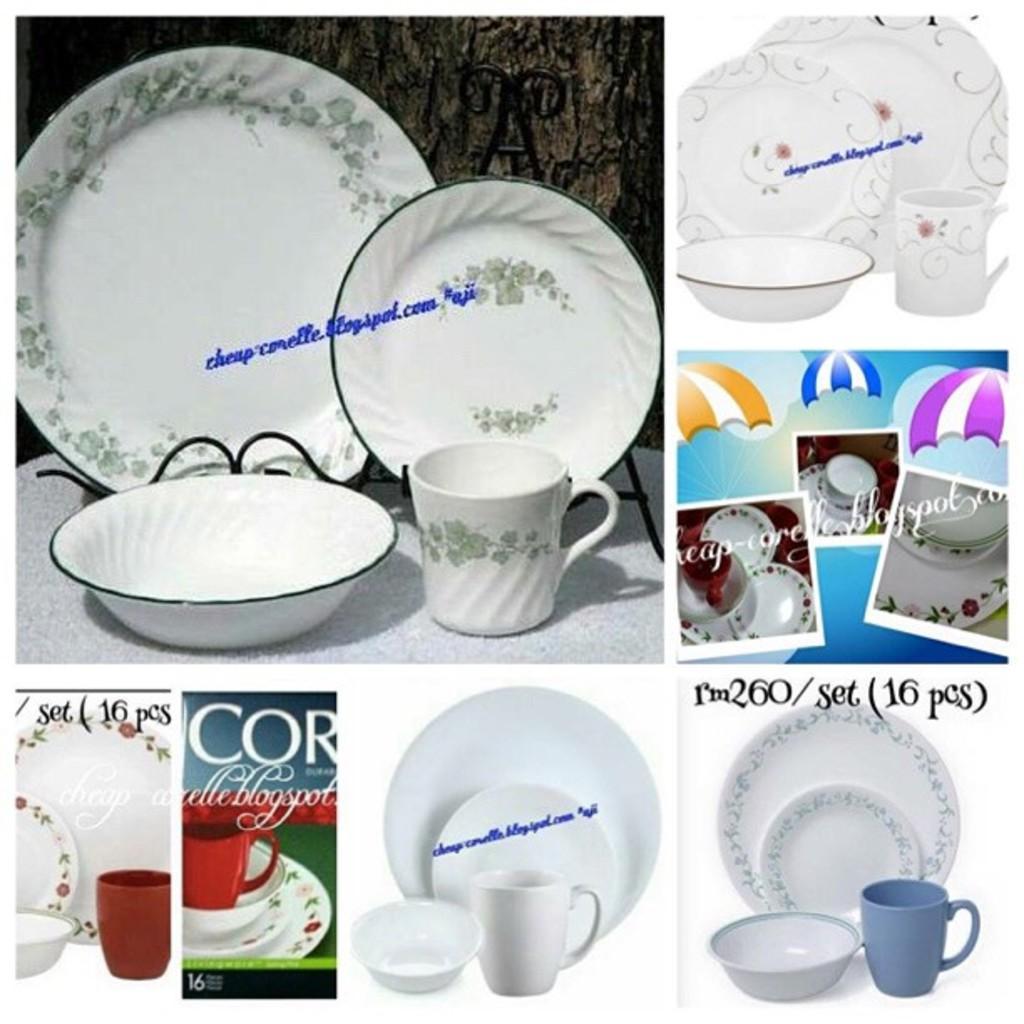In one or two sentences, can you explain what this image depicts? Here we can see collage of pictures, in these pictures we can see plates, mugs, bowls and some text. 